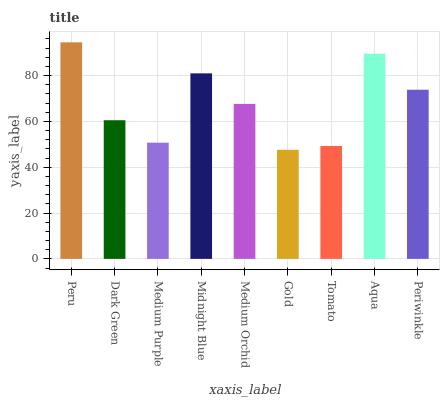Is Gold the minimum?
Answer yes or no. Yes. Is Peru the maximum?
Answer yes or no. Yes. Is Dark Green the minimum?
Answer yes or no. No. Is Dark Green the maximum?
Answer yes or no. No. Is Peru greater than Dark Green?
Answer yes or no. Yes. Is Dark Green less than Peru?
Answer yes or no. Yes. Is Dark Green greater than Peru?
Answer yes or no. No. Is Peru less than Dark Green?
Answer yes or no. No. Is Medium Orchid the high median?
Answer yes or no. Yes. Is Medium Orchid the low median?
Answer yes or no. Yes. Is Midnight Blue the high median?
Answer yes or no. No. Is Tomato the low median?
Answer yes or no. No. 